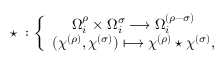<formula> <loc_0><loc_0><loc_500><loc_500>^ { * } \, \colon \left \{ \begin{array} { c } { { \Omega _ { i } ^ { \rho } \times \Omega _ { i } ^ { \sigma } \longrightarrow \Omega _ { i } ^ { ( \rho - \sigma ) } } } \\ { { ( \chi ^ { ( \rho ) } , \chi ^ { ( \sigma ) } ) \longmapsto \chi ^ { ( \rho ) } ^ { * } \chi ^ { ( \sigma ) } , } } \end{array}</formula> 